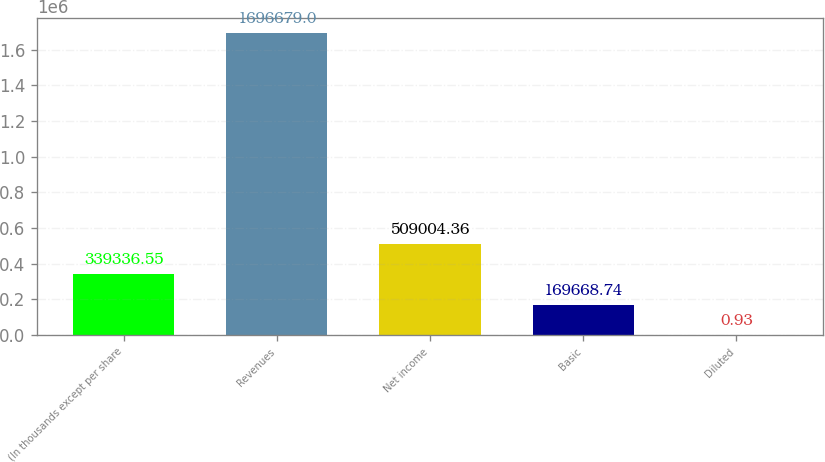<chart> <loc_0><loc_0><loc_500><loc_500><bar_chart><fcel>(In thousands except per share<fcel>Revenues<fcel>Net income<fcel>Basic<fcel>Diluted<nl><fcel>339337<fcel>1.69668e+06<fcel>509004<fcel>169669<fcel>0.93<nl></chart> 